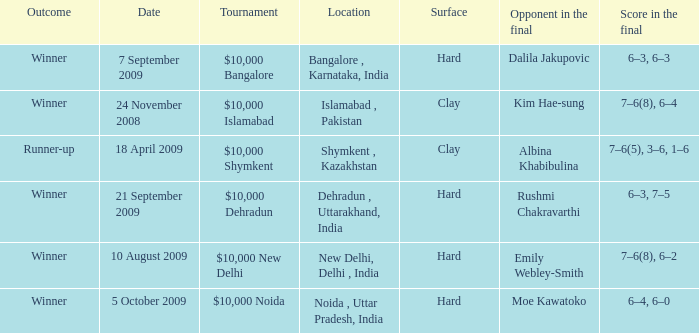In how many dates the opponen in the final was rushmi chakravarthi 1.0. 